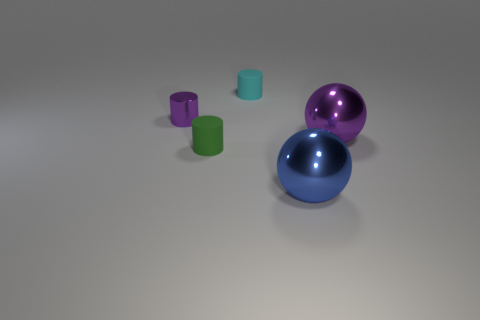Is the number of small red cubes less than the number of tiny cyan matte things?
Keep it short and to the point. Yes. There is a tiny shiny object; does it have the same color as the tiny matte cylinder on the left side of the cyan rubber cylinder?
Your response must be concise. No. Are there an equal number of purple shiny objects that are in front of the tiny green object and purple cylinders that are to the right of the small cyan thing?
Provide a short and direct response. Yes. What number of tiny purple objects have the same shape as the green object?
Give a very brief answer. 1. Are there any big yellow rubber spheres?
Provide a short and direct response. No. Is the material of the tiny purple object the same as the purple object to the right of the small cyan matte cylinder?
Keep it short and to the point. Yes. There is another ball that is the same size as the purple metallic sphere; what is its material?
Keep it short and to the point. Metal. Are there any small cyan things that have the same material as the cyan cylinder?
Your response must be concise. No. Are there any tiny green things on the left side of the big shiny sphere that is in front of the matte cylinder in front of the purple shiny cylinder?
Your answer should be very brief. Yes. There is a purple metal object that is the same size as the cyan cylinder; what shape is it?
Give a very brief answer. Cylinder. 